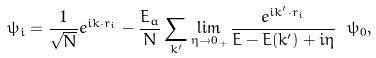Convert formula to latex. <formula><loc_0><loc_0><loc_500><loc_500>\psi _ { i } = \frac { 1 } { \sqrt { N } } e ^ { i { k } \cdot { r } _ { i } } - \frac { E _ { a } } { N } \sum _ { k ^ { \prime } } \lim _ { \eta \rightarrow 0 _ { + } } \frac { e ^ { i { k ^ { \prime } } \cdot { r } _ { i } } } { E - E ( k ^ { \prime } ) + i \eta } \ \psi _ { 0 } ,</formula> 